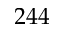Convert formula to latex. <formula><loc_0><loc_0><loc_500><loc_500>2 4 4</formula> 